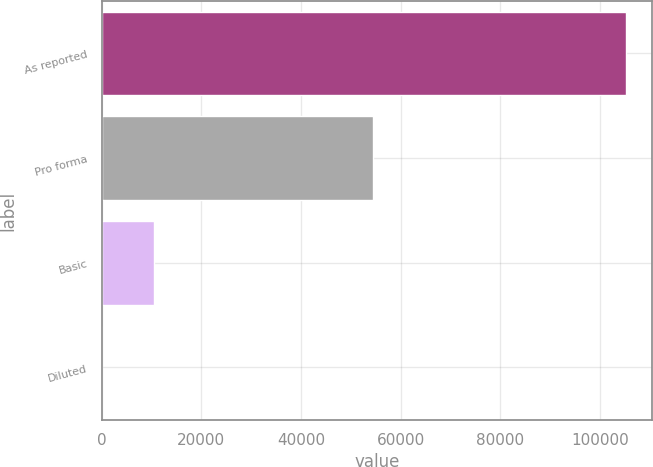Convert chart. <chart><loc_0><loc_0><loc_500><loc_500><bar_chart><fcel>As reported<fcel>Pro forma<fcel>Basic<fcel>Diluted<nl><fcel>105144<fcel>54435<fcel>10515.1<fcel>0.77<nl></chart> 